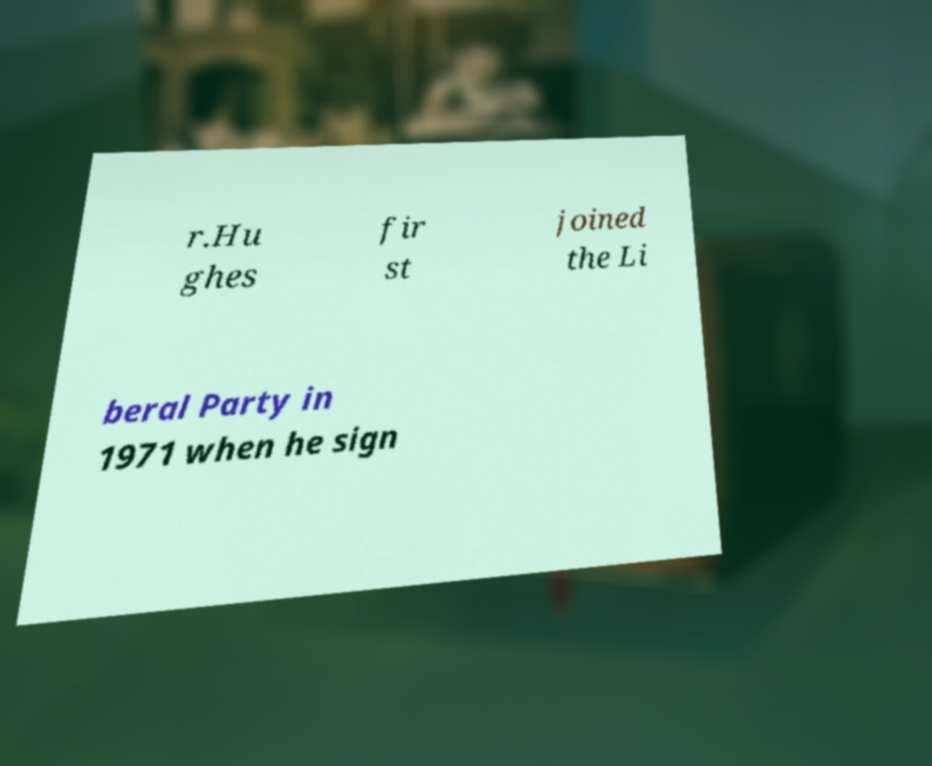What messages or text are displayed in this image? I need them in a readable, typed format. r.Hu ghes fir st joined the Li beral Party in 1971 when he sign 